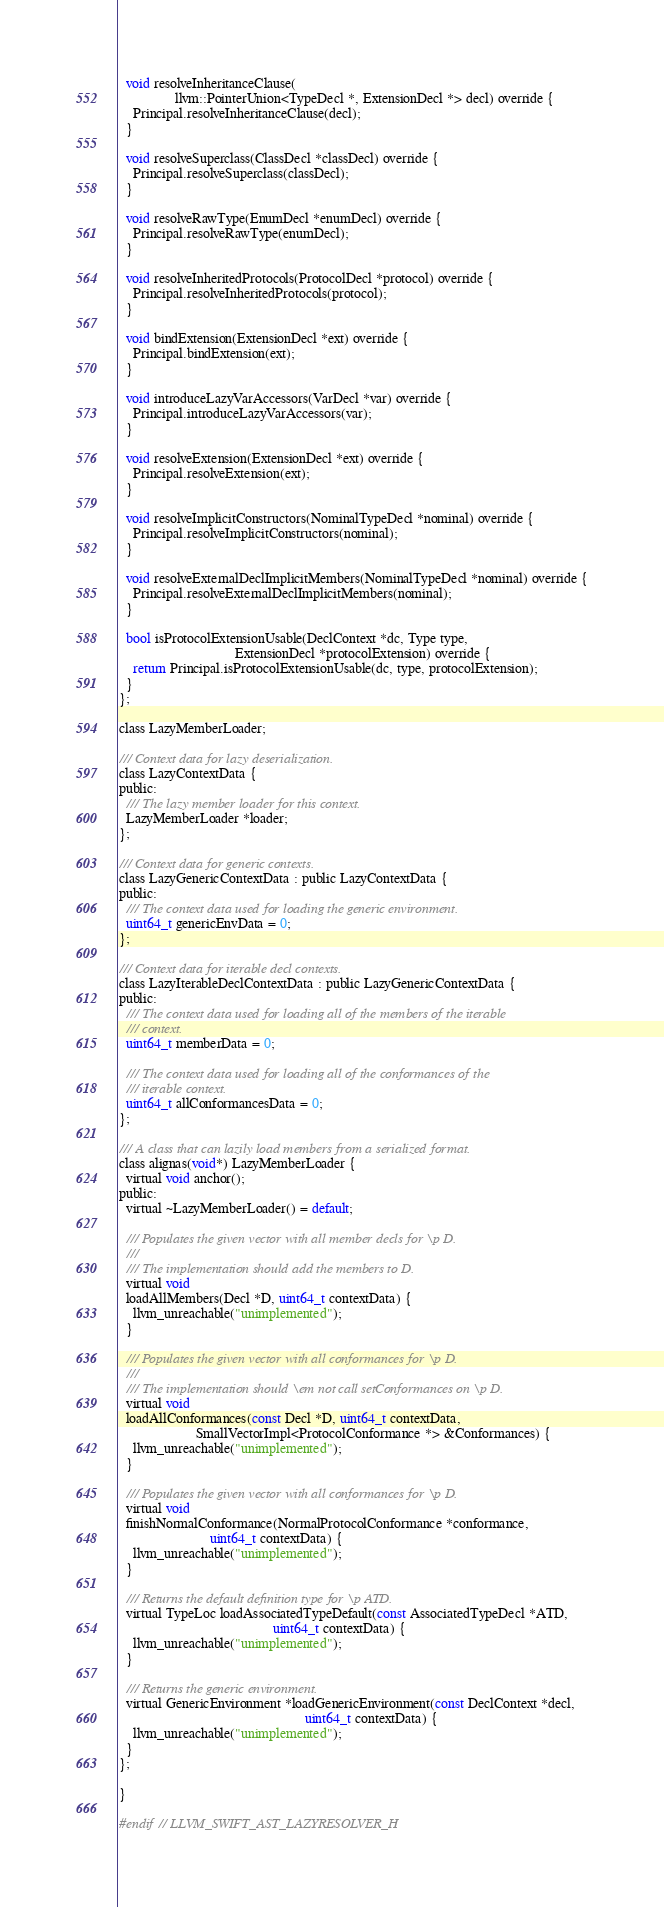Convert code to text. <code><loc_0><loc_0><loc_500><loc_500><_C_>  void resolveInheritanceClause(
                llvm::PointerUnion<TypeDecl *, ExtensionDecl *> decl) override {
    Principal.resolveInheritanceClause(decl);
  }

  void resolveSuperclass(ClassDecl *classDecl) override {
    Principal.resolveSuperclass(classDecl);
  }

  void resolveRawType(EnumDecl *enumDecl) override {
    Principal.resolveRawType(enumDecl);
  }

  void resolveInheritedProtocols(ProtocolDecl *protocol) override {
    Principal.resolveInheritedProtocols(protocol);
  }

  void bindExtension(ExtensionDecl *ext) override {
    Principal.bindExtension(ext);
  }

  void introduceLazyVarAccessors(VarDecl *var) override {
    Principal.introduceLazyVarAccessors(var);
  }

  void resolveExtension(ExtensionDecl *ext) override {
    Principal.resolveExtension(ext);
  }

  void resolveImplicitConstructors(NominalTypeDecl *nominal) override {
    Principal.resolveImplicitConstructors(nominal);
  }

  void resolveExternalDeclImplicitMembers(NominalTypeDecl *nominal) override {
    Principal.resolveExternalDeclImplicitMembers(nominal);
  }

  bool isProtocolExtensionUsable(DeclContext *dc, Type type,
                                 ExtensionDecl *protocolExtension) override {
    return Principal.isProtocolExtensionUsable(dc, type, protocolExtension);
  }
};

class LazyMemberLoader;

/// Context data for lazy deserialization.
class LazyContextData {
public:
  /// The lazy member loader for this context.
  LazyMemberLoader *loader;
};

/// Context data for generic contexts.
class LazyGenericContextData : public LazyContextData {
public:
  /// The context data used for loading the generic environment.
  uint64_t genericEnvData = 0;
};

/// Context data for iterable decl contexts.
class LazyIterableDeclContextData : public LazyGenericContextData {
public:
  /// The context data used for loading all of the members of the iterable
  /// context.
  uint64_t memberData = 0;

  /// The context data used for loading all of the conformances of the
  /// iterable context.
  uint64_t allConformancesData = 0;
};

/// A class that can lazily load members from a serialized format.
class alignas(void*) LazyMemberLoader {
  virtual void anchor();
public:
  virtual ~LazyMemberLoader() = default;

  /// Populates the given vector with all member decls for \p D.
  ///
  /// The implementation should add the members to D.
  virtual void
  loadAllMembers(Decl *D, uint64_t contextData) {
    llvm_unreachable("unimplemented");
  }

  /// Populates the given vector with all conformances for \p D.
  ///
  /// The implementation should \em not call setConformances on \p D.
  virtual void
  loadAllConformances(const Decl *D, uint64_t contextData,
                      SmallVectorImpl<ProtocolConformance *> &Conformances) {
    llvm_unreachable("unimplemented");
  }

  /// Populates the given vector with all conformances for \p D.
  virtual void
  finishNormalConformance(NormalProtocolConformance *conformance,
                          uint64_t contextData) {
    llvm_unreachable("unimplemented");
  }

  /// Returns the default definition type for \p ATD.
  virtual TypeLoc loadAssociatedTypeDefault(const AssociatedTypeDecl *ATD,
                                            uint64_t contextData) {
    llvm_unreachable("unimplemented");
  }

  /// Returns the generic environment.
  virtual GenericEnvironment *loadGenericEnvironment(const DeclContext *decl,
                                                     uint64_t contextData) {
    llvm_unreachable("unimplemented");
  }
};

}

#endif // LLVM_SWIFT_AST_LAZYRESOLVER_H
</code> 